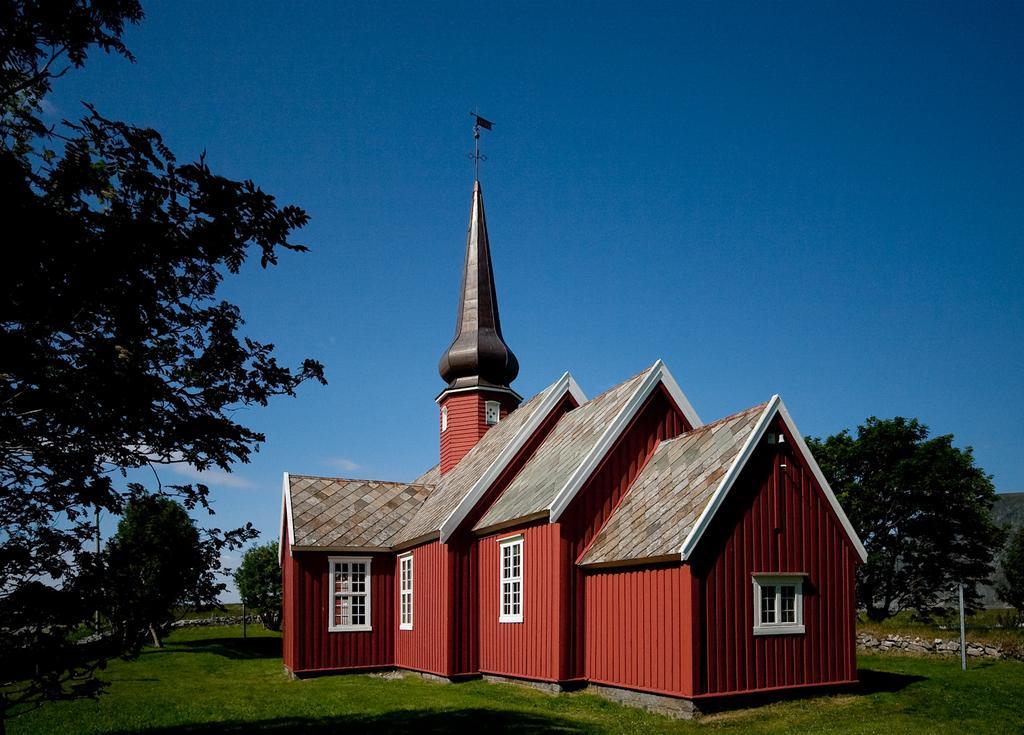In one or two sentences, can you explain what this image depicts? In this image we can see a house, trees, grass. At the top of the image there is sky. 